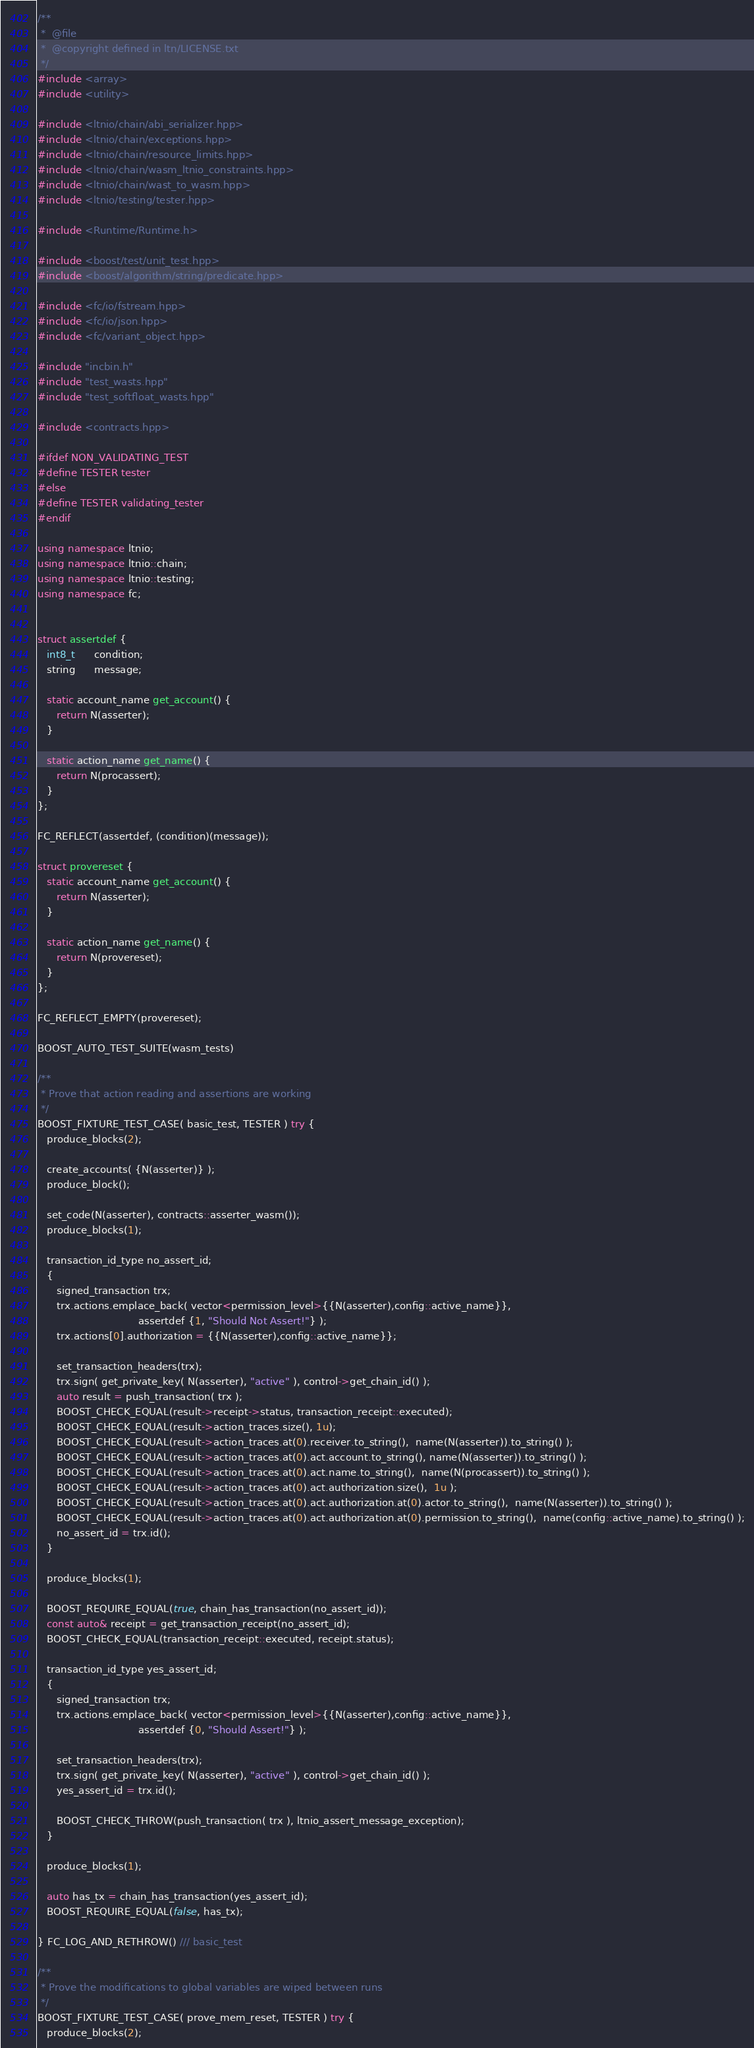Convert code to text. <code><loc_0><loc_0><loc_500><loc_500><_C++_>/**
 *  @file
 *  @copyright defined in ltn/LICENSE.txt
 */
#include <array>
#include <utility>

#include <ltnio/chain/abi_serializer.hpp>
#include <ltnio/chain/exceptions.hpp>
#include <ltnio/chain/resource_limits.hpp>
#include <ltnio/chain/wasm_ltnio_constraints.hpp>
#include <ltnio/chain/wast_to_wasm.hpp>
#include <ltnio/testing/tester.hpp>

#include <Runtime/Runtime.h>

#include <boost/test/unit_test.hpp>
#include <boost/algorithm/string/predicate.hpp>

#include <fc/io/fstream.hpp>
#include <fc/io/json.hpp>
#include <fc/variant_object.hpp>

#include "incbin.h"
#include "test_wasts.hpp"
#include "test_softfloat_wasts.hpp"

#include <contracts.hpp>

#ifdef NON_VALIDATING_TEST
#define TESTER tester
#else
#define TESTER validating_tester
#endif

using namespace ltnio;
using namespace ltnio::chain;
using namespace ltnio::testing;
using namespace fc;


struct assertdef {
   int8_t      condition;
   string      message;

   static account_name get_account() {
      return N(asserter);
   }

   static action_name get_name() {
      return N(procassert);
   }
};

FC_REFLECT(assertdef, (condition)(message));

struct provereset {
   static account_name get_account() {
      return N(asserter);
   }

   static action_name get_name() {
      return N(provereset);
   }
};

FC_REFLECT_EMPTY(provereset);

BOOST_AUTO_TEST_SUITE(wasm_tests)

/**
 * Prove that action reading and assertions are working
 */
BOOST_FIXTURE_TEST_CASE( basic_test, TESTER ) try {
   produce_blocks(2);

   create_accounts( {N(asserter)} );
   produce_block();

   set_code(N(asserter), contracts::asserter_wasm());
   produce_blocks(1);

   transaction_id_type no_assert_id;
   {
      signed_transaction trx;
      trx.actions.emplace_back( vector<permission_level>{{N(asserter),config::active_name}},
                                assertdef {1, "Should Not Assert!"} );
      trx.actions[0].authorization = {{N(asserter),config::active_name}};

      set_transaction_headers(trx);
      trx.sign( get_private_key( N(asserter), "active" ), control->get_chain_id() );
      auto result = push_transaction( trx );
      BOOST_CHECK_EQUAL(result->receipt->status, transaction_receipt::executed);
      BOOST_CHECK_EQUAL(result->action_traces.size(), 1u);
      BOOST_CHECK_EQUAL(result->action_traces.at(0).receiver.to_string(),  name(N(asserter)).to_string() );
      BOOST_CHECK_EQUAL(result->action_traces.at(0).act.account.to_string(), name(N(asserter)).to_string() );
      BOOST_CHECK_EQUAL(result->action_traces.at(0).act.name.to_string(),  name(N(procassert)).to_string() );
      BOOST_CHECK_EQUAL(result->action_traces.at(0).act.authorization.size(),  1u );
      BOOST_CHECK_EQUAL(result->action_traces.at(0).act.authorization.at(0).actor.to_string(),  name(N(asserter)).to_string() );
      BOOST_CHECK_EQUAL(result->action_traces.at(0).act.authorization.at(0).permission.to_string(),  name(config::active_name).to_string() );
      no_assert_id = trx.id();
   }

   produce_blocks(1);

   BOOST_REQUIRE_EQUAL(true, chain_has_transaction(no_assert_id));
   const auto& receipt = get_transaction_receipt(no_assert_id);
   BOOST_CHECK_EQUAL(transaction_receipt::executed, receipt.status);

   transaction_id_type yes_assert_id;
   {
      signed_transaction trx;
      trx.actions.emplace_back( vector<permission_level>{{N(asserter),config::active_name}},
                                assertdef {0, "Should Assert!"} );

      set_transaction_headers(trx);
      trx.sign( get_private_key( N(asserter), "active" ), control->get_chain_id() );
      yes_assert_id = trx.id();

      BOOST_CHECK_THROW(push_transaction( trx ), ltnio_assert_message_exception);
   }

   produce_blocks(1);

   auto has_tx = chain_has_transaction(yes_assert_id);
   BOOST_REQUIRE_EQUAL(false, has_tx);

} FC_LOG_AND_RETHROW() /// basic_test

/**
 * Prove the modifications to global variables are wiped between runs
 */
BOOST_FIXTURE_TEST_CASE( prove_mem_reset, TESTER ) try {
   produce_blocks(2);
</code> 